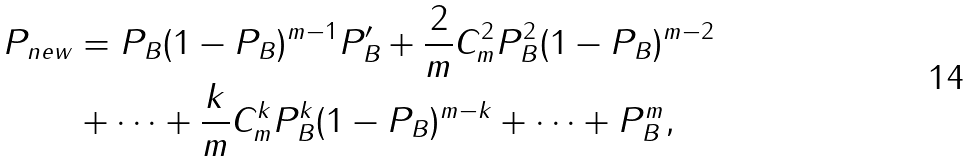Convert formula to latex. <formula><loc_0><loc_0><loc_500><loc_500>P _ { n e w } & = P _ { B } ( 1 - P _ { B } ) ^ { m - 1 } P ^ { \prime } _ { B } + \frac { 2 } { m } C _ { m } ^ { 2 } P _ { B } ^ { 2 } ( 1 - P _ { B } ) ^ { m - 2 } \\ & + \dots + \frac { k } { m } C _ { m } ^ { k } P _ { B } ^ { k } ( 1 - P _ { B } ) ^ { m - k } + \dots + P _ { B } ^ { m } ,</formula> 